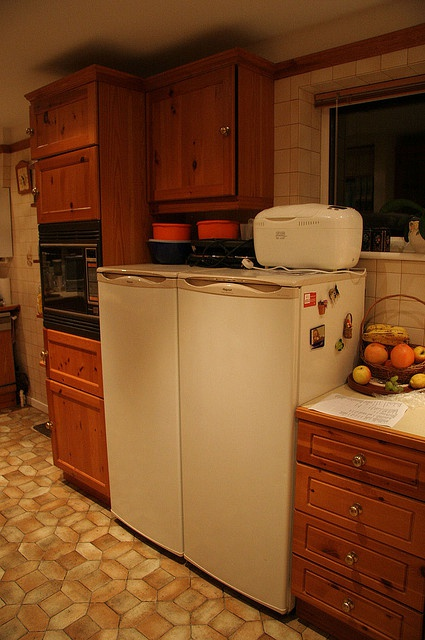Describe the objects in this image and their specific colors. I can see refrigerator in maroon, tan, and olive tones, microwave in maroon, black, and brown tones, banana in maroon, brown, and orange tones, orange in maroon, red, and brown tones, and orange in maroon, brown, and red tones in this image. 